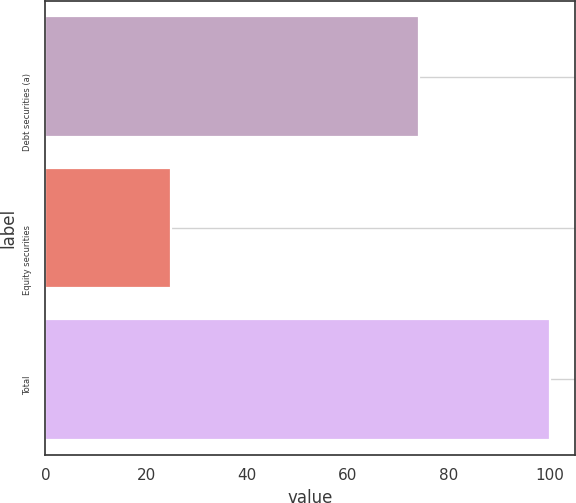Convert chart. <chart><loc_0><loc_0><loc_500><loc_500><bar_chart><fcel>Debt securities (a)<fcel>Equity securities<fcel>Total<nl><fcel>74<fcel>25<fcel>100<nl></chart> 